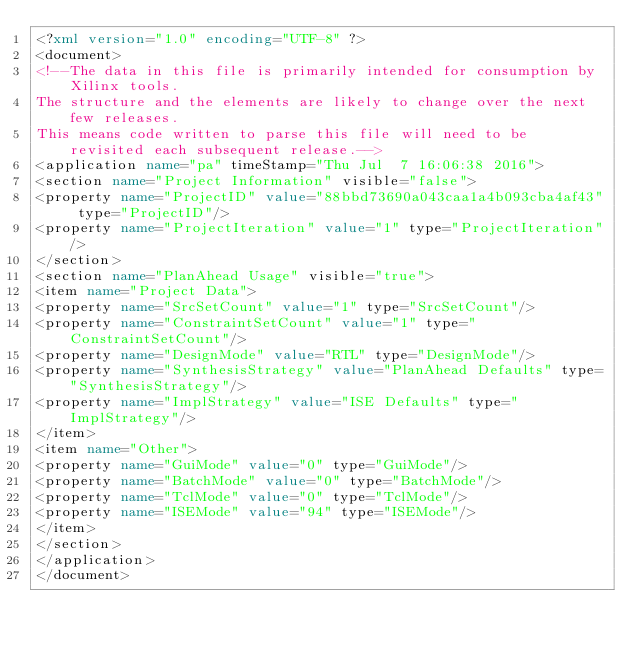Convert code to text. <code><loc_0><loc_0><loc_500><loc_500><_XML_><?xml version="1.0" encoding="UTF-8" ?>
<document>
<!--The data in this file is primarily intended for consumption by Xilinx tools.
The structure and the elements are likely to change over the next few releases.
This means code written to parse this file will need to be revisited each subsequent release.-->
<application name="pa" timeStamp="Thu Jul  7 16:06:38 2016">
<section name="Project Information" visible="false">
<property name="ProjectID" value="88bbd73690a043caa1a4b093cba4af43" type="ProjectID"/>
<property name="ProjectIteration" value="1" type="ProjectIteration"/>
</section>
<section name="PlanAhead Usage" visible="true">
<item name="Project Data">
<property name="SrcSetCount" value="1" type="SrcSetCount"/>
<property name="ConstraintSetCount" value="1" type="ConstraintSetCount"/>
<property name="DesignMode" value="RTL" type="DesignMode"/>
<property name="SynthesisStrategy" value="PlanAhead Defaults" type="SynthesisStrategy"/>
<property name="ImplStrategy" value="ISE Defaults" type="ImplStrategy"/>
</item>
<item name="Other">
<property name="GuiMode" value="0" type="GuiMode"/>
<property name="BatchMode" value="0" type="BatchMode"/>
<property name="TclMode" value="0" type="TclMode"/>
<property name="ISEMode" value="94" type="ISEMode"/>
</item>
</section>
</application>
</document>
</code> 